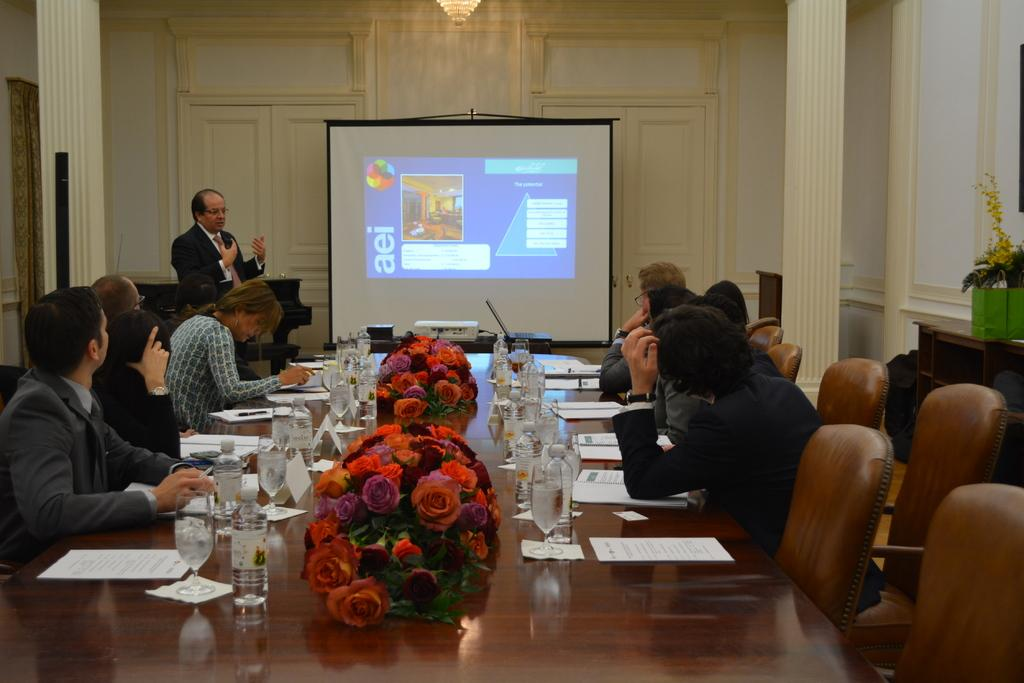What are the people in the image doing? The people in the image are sitting on chairs. What can be seen on the table in the image? There are glasses on a table in the image. What is located in the background of the image? There is a projector, a man standing, and a wooden wall in the background of the image. Are there any plants visible in the image? Yes, there are flower pots in the image. What type of bead is being used as a decoration on the man's vest in the image? There is no man wearing a vest in the image, and therefore no bead decoration can be observed. 